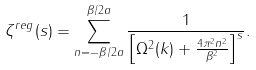Convert formula to latex. <formula><loc_0><loc_0><loc_500><loc_500>\zeta ^ { r e g } ( s ) = \sum _ { n = - \beta / 2 a } ^ { \beta / 2 a } \frac { 1 } { \left [ \Omega ^ { 2 } ( k ) + \frac { 4 \pi ^ { 2 } n ^ { 2 } } { \beta ^ { 2 } } \right ] ^ { s } } .</formula> 